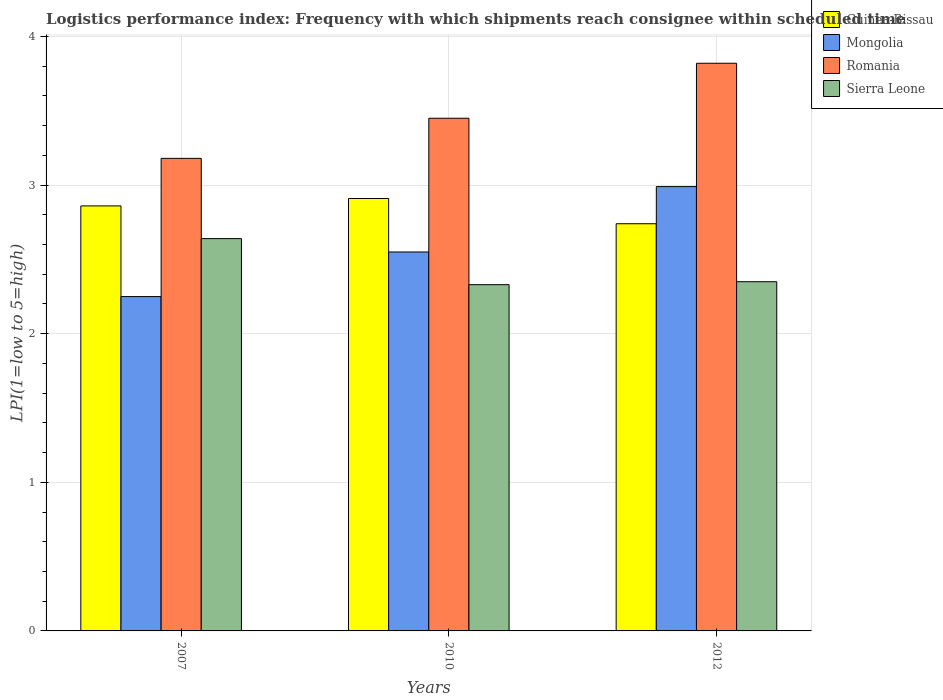How many different coloured bars are there?
Provide a short and direct response. 4. How many groups of bars are there?
Your response must be concise. 3. Are the number of bars on each tick of the X-axis equal?
Your answer should be very brief. Yes. How many bars are there on the 3rd tick from the right?
Keep it short and to the point. 4. What is the label of the 2nd group of bars from the left?
Offer a terse response. 2010. What is the logistics performance index in Sierra Leone in 2010?
Provide a succinct answer. 2.33. Across all years, what is the maximum logistics performance index in Guinea-Bissau?
Give a very brief answer. 2.91. Across all years, what is the minimum logistics performance index in Sierra Leone?
Give a very brief answer. 2.33. In which year was the logistics performance index in Romania maximum?
Keep it short and to the point. 2012. What is the total logistics performance index in Sierra Leone in the graph?
Make the answer very short. 7.32. What is the difference between the logistics performance index in Mongolia in 2010 and that in 2012?
Your response must be concise. -0.44. What is the difference between the logistics performance index in Mongolia in 2010 and the logistics performance index in Guinea-Bissau in 2012?
Give a very brief answer. -0.19. What is the average logistics performance index in Guinea-Bissau per year?
Ensure brevity in your answer.  2.84. In the year 2012, what is the difference between the logistics performance index in Guinea-Bissau and logistics performance index in Romania?
Offer a terse response. -1.08. In how many years, is the logistics performance index in Mongolia greater than 0.6000000000000001?
Ensure brevity in your answer.  3. What is the ratio of the logistics performance index in Sierra Leone in 2007 to that in 2010?
Make the answer very short. 1.13. Is the difference between the logistics performance index in Guinea-Bissau in 2007 and 2010 greater than the difference between the logistics performance index in Romania in 2007 and 2010?
Provide a succinct answer. Yes. What is the difference between the highest and the second highest logistics performance index in Guinea-Bissau?
Provide a succinct answer. 0.05. What is the difference between the highest and the lowest logistics performance index in Sierra Leone?
Give a very brief answer. 0.31. Is it the case that in every year, the sum of the logistics performance index in Sierra Leone and logistics performance index in Guinea-Bissau is greater than the sum of logistics performance index in Mongolia and logistics performance index in Romania?
Give a very brief answer. No. What does the 4th bar from the left in 2010 represents?
Your answer should be compact. Sierra Leone. What does the 1st bar from the right in 2007 represents?
Your answer should be very brief. Sierra Leone. Is it the case that in every year, the sum of the logistics performance index in Romania and logistics performance index in Mongolia is greater than the logistics performance index in Sierra Leone?
Make the answer very short. Yes. How many years are there in the graph?
Provide a succinct answer. 3. What is the difference between two consecutive major ticks on the Y-axis?
Give a very brief answer. 1. Does the graph contain any zero values?
Ensure brevity in your answer.  No. Where does the legend appear in the graph?
Your answer should be compact. Top right. How are the legend labels stacked?
Keep it short and to the point. Vertical. What is the title of the graph?
Provide a short and direct response. Logistics performance index: Frequency with which shipments reach consignee within scheduled time. Does "Peru" appear as one of the legend labels in the graph?
Make the answer very short. No. What is the label or title of the X-axis?
Your answer should be very brief. Years. What is the label or title of the Y-axis?
Ensure brevity in your answer.  LPI(1=low to 5=high). What is the LPI(1=low to 5=high) of Guinea-Bissau in 2007?
Your answer should be compact. 2.86. What is the LPI(1=low to 5=high) of Mongolia in 2007?
Offer a very short reply. 2.25. What is the LPI(1=low to 5=high) of Romania in 2007?
Your answer should be very brief. 3.18. What is the LPI(1=low to 5=high) in Sierra Leone in 2007?
Offer a very short reply. 2.64. What is the LPI(1=low to 5=high) of Guinea-Bissau in 2010?
Provide a succinct answer. 2.91. What is the LPI(1=low to 5=high) of Mongolia in 2010?
Your answer should be compact. 2.55. What is the LPI(1=low to 5=high) of Romania in 2010?
Your answer should be compact. 3.45. What is the LPI(1=low to 5=high) of Sierra Leone in 2010?
Provide a succinct answer. 2.33. What is the LPI(1=low to 5=high) of Guinea-Bissau in 2012?
Your response must be concise. 2.74. What is the LPI(1=low to 5=high) of Mongolia in 2012?
Offer a very short reply. 2.99. What is the LPI(1=low to 5=high) of Romania in 2012?
Ensure brevity in your answer.  3.82. What is the LPI(1=low to 5=high) in Sierra Leone in 2012?
Ensure brevity in your answer.  2.35. Across all years, what is the maximum LPI(1=low to 5=high) of Guinea-Bissau?
Keep it short and to the point. 2.91. Across all years, what is the maximum LPI(1=low to 5=high) in Mongolia?
Provide a succinct answer. 2.99. Across all years, what is the maximum LPI(1=low to 5=high) in Romania?
Give a very brief answer. 3.82. Across all years, what is the maximum LPI(1=low to 5=high) in Sierra Leone?
Ensure brevity in your answer.  2.64. Across all years, what is the minimum LPI(1=low to 5=high) of Guinea-Bissau?
Keep it short and to the point. 2.74. Across all years, what is the minimum LPI(1=low to 5=high) of Mongolia?
Provide a succinct answer. 2.25. Across all years, what is the minimum LPI(1=low to 5=high) in Romania?
Give a very brief answer. 3.18. Across all years, what is the minimum LPI(1=low to 5=high) of Sierra Leone?
Keep it short and to the point. 2.33. What is the total LPI(1=low to 5=high) of Guinea-Bissau in the graph?
Your answer should be compact. 8.51. What is the total LPI(1=low to 5=high) in Mongolia in the graph?
Your answer should be compact. 7.79. What is the total LPI(1=low to 5=high) in Romania in the graph?
Keep it short and to the point. 10.45. What is the total LPI(1=low to 5=high) in Sierra Leone in the graph?
Your answer should be very brief. 7.32. What is the difference between the LPI(1=low to 5=high) in Romania in 2007 and that in 2010?
Offer a terse response. -0.27. What is the difference between the LPI(1=low to 5=high) of Sierra Leone in 2007 and that in 2010?
Offer a very short reply. 0.31. What is the difference between the LPI(1=low to 5=high) in Guinea-Bissau in 2007 and that in 2012?
Provide a succinct answer. 0.12. What is the difference between the LPI(1=low to 5=high) of Mongolia in 2007 and that in 2012?
Your answer should be compact. -0.74. What is the difference between the LPI(1=low to 5=high) in Romania in 2007 and that in 2012?
Provide a succinct answer. -0.64. What is the difference between the LPI(1=low to 5=high) in Sierra Leone in 2007 and that in 2012?
Ensure brevity in your answer.  0.29. What is the difference between the LPI(1=low to 5=high) in Guinea-Bissau in 2010 and that in 2012?
Keep it short and to the point. 0.17. What is the difference between the LPI(1=low to 5=high) in Mongolia in 2010 and that in 2012?
Offer a very short reply. -0.44. What is the difference between the LPI(1=low to 5=high) of Romania in 2010 and that in 2012?
Your response must be concise. -0.37. What is the difference between the LPI(1=low to 5=high) of Sierra Leone in 2010 and that in 2012?
Keep it short and to the point. -0.02. What is the difference between the LPI(1=low to 5=high) in Guinea-Bissau in 2007 and the LPI(1=low to 5=high) in Mongolia in 2010?
Your response must be concise. 0.31. What is the difference between the LPI(1=low to 5=high) in Guinea-Bissau in 2007 and the LPI(1=low to 5=high) in Romania in 2010?
Your response must be concise. -0.59. What is the difference between the LPI(1=low to 5=high) in Guinea-Bissau in 2007 and the LPI(1=low to 5=high) in Sierra Leone in 2010?
Your answer should be very brief. 0.53. What is the difference between the LPI(1=low to 5=high) of Mongolia in 2007 and the LPI(1=low to 5=high) of Sierra Leone in 2010?
Your answer should be compact. -0.08. What is the difference between the LPI(1=low to 5=high) in Guinea-Bissau in 2007 and the LPI(1=low to 5=high) in Mongolia in 2012?
Offer a terse response. -0.13. What is the difference between the LPI(1=low to 5=high) in Guinea-Bissau in 2007 and the LPI(1=low to 5=high) in Romania in 2012?
Offer a terse response. -0.96. What is the difference between the LPI(1=low to 5=high) of Guinea-Bissau in 2007 and the LPI(1=low to 5=high) of Sierra Leone in 2012?
Keep it short and to the point. 0.51. What is the difference between the LPI(1=low to 5=high) in Mongolia in 2007 and the LPI(1=low to 5=high) in Romania in 2012?
Your answer should be compact. -1.57. What is the difference between the LPI(1=low to 5=high) of Romania in 2007 and the LPI(1=low to 5=high) of Sierra Leone in 2012?
Offer a terse response. 0.83. What is the difference between the LPI(1=low to 5=high) of Guinea-Bissau in 2010 and the LPI(1=low to 5=high) of Mongolia in 2012?
Offer a terse response. -0.08. What is the difference between the LPI(1=low to 5=high) in Guinea-Bissau in 2010 and the LPI(1=low to 5=high) in Romania in 2012?
Ensure brevity in your answer.  -0.91. What is the difference between the LPI(1=low to 5=high) of Guinea-Bissau in 2010 and the LPI(1=low to 5=high) of Sierra Leone in 2012?
Your answer should be compact. 0.56. What is the difference between the LPI(1=low to 5=high) in Mongolia in 2010 and the LPI(1=low to 5=high) in Romania in 2012?
Keep it short and to the point. -1.27. What is the average LPI(1=low to 5=high) of Guinea-Bissau per year?
Ensure brevity in your answer.  2.84. What is the average LPI(1=low to 5=high) of Mongolia per year?
Make the answer very short. 2.6. What is the average LPI(1=low to 5=high) in Romania per year?
Your response must be concise. 3.48. What is the average LPI(1=low to 5=high) of Sierra Leone per year?
Your answer should be very brief. 2.44. In the year 2007, what is the difference between the LPI(1=low to 5=high) of Guinea-Bissau and LPI(1=low to 5=high) of Mongolia?
Provide a short and direct response. 0.61. In the year 2007, what is the difference between the LPI(1=low to 5=high) of Guinea-Bissau and LPI(1=low to 5=high) of Romania?
Keep it short and to the point. -0.32. In the year 2007, what is the difference between the LPI(1=low to 5=high) in Guinea-Bissau and LPI(1=low to 5=high) in Sierra Leone?
Your answer should be very brief. 0.22. In the year 2007, what is the difference between the LPI(1=low to 5=high) in Mongolia and LPI(1=low to 5=high) in Romania?
Your response must be concise. -0.93. In the year 2007, what is the difference between the LPI(1=low to 5=high) of Mongolia and LPI(1=low to 5=high) of Sierra Leone?
Offer a very short reply. -0.39. In the year 2007, what is the difference between the LPI(1=low to 5=high) of Romania and LPI(1=low to 5=high) of Sierra Leone?
Offer a very short reply. 0.54. In the year 2010, what is the difference between the LPI(1=low to 5=high) of Guinea-Bissau and LPI(1=low to 5=high) of Mongolia?
Offer a very short reply. 0.36. In the year 2010, what is the difference between the LPI(1=low to 5=high) in Guinea-Bissau and LPI(1=low to 5=high) in Romania?
Ensure brevity in your answer.  -0.54. In the year 2010, what is the difference between the LPI(1=low to 5=high) of Guinea-Bissau and LPI(1=low to 5=high) of Sierra Leone?
Give a very brief answer. 0.58. In the year 2010, what is the difference between the LPI(1=low to 5=high) in Mongolia and LPI(1=low to 5=high) in Sierra Leone?
Offer a very short reply. 0.22. In the year 2010, what is the difference between the LPI(1=low to 5=high) of Romania and LPI(1=low to 5=high) of Sierra Leone?
Keep it short and to the point. 1.12. In the year 2012, what is the difference between the LPI(1=low to 5=high) of Guinea-Bissau and LPI(1=low to 5=high) of Mongolia?
Keep it short and to the point. -0.25. In the year 2012, what is the difference between the LPI(1=low to 5=high) of Guinea-Bissau and LPI(1=low to 5=high) of Romania?
Your answer should be compact. -1.08. In the year 2012, what is the difference between the LPI(1=low to 5=high) of Guinea-Bissau and LPI(1=low to 5=high) of Sierra Leone?
Give a very brief answer. 0.39. In the year 2012, what is the difference between the LPI(1=low to 5=high) of Mongolia and LPI(1=low to 5=high) of Romania?
Ensure brevity in your answer.  -0.83. In the year 2012, what is the difference between the LPI(1=low to 5=high) in Mongolia and LPI(1=low to 5=high) in Sierra Leone?
Ensure brevity in your answer.  0.64. In the year 2012, what is the difference between the LPI(1=low to 5=high) of Romania and LPI(1=low to 5=high) of Sierra Leone?
Your response must be concise. 1.47. What is the ratio of the LPI(1=low to 5=high) in Guinea-Bissau in 2007 to that in 2010?
Your answer should be compact. 0.98. What is the ratio of the LPI(1=low to 5=high) in Mongolia in 2007 to that in 2010?
Offer a very short reply. 0.88. What is the ratio of the LPI(1=low to 5=high) in Romania in 2007 to that in 2010?
Offer a terse response. 0.92. What is the ratio of the LPI(1=low to 5=high) of Sierra Leone in 2007 to that in 2010?
Make the answer very short. 1.13. What is the ratio of the LPI(1=low to 5=high) in Guinea-Bissau in 2007 to that in 2012?
Make the answer very short. 1.04. What is the ratio of the LPI(1=low to 5=high) in Mongolia in 2007 to that in 2012?
Provide a succinct answer. 0.75. What is the ratio of the LPI(1=low to 5=high) of Romania in 2007 to that in 2012?
Offer a very short reply. 0.83. What is the ratio of the LPI(1=low to 5=high) of Sierra Leone in 2007 to that in 2012?
Ensure brevity in your answer.  1.12. What is the ratio of the LPI(1=low to 5=high) in Guinea-Bissau in 2010 to that in 2012?
Ensure brevity in your answer.  1.06. What is the ratio of the LPI(1=low to 5=high) of Mongolia in 2010 to that in 2012?
Your response must be concise. 0.85. What is the ratio of the LPI(1=low to 5=high) in Romania in 2010 to that in 2012?
Ensure brevity in your answer.  0.9. What is the difference between the highest and the second highest LPI(1=low to 5=high) of Guinea-Bissau?
Your answer should be very brief. 0.05. What is the difference between the highest and the second highest LPI(1=low to 5=high) of Mongolia?
Keep it short and to the point. 0.44. What is the difference between the highest and the second highest LPI(1=low to 5=high) of Romania?
Your response must be concise. 0.37. What is the difference between the highest and the second highest LPI(1=low to 5=high) of Sierra Leone?
Ensure brevity in your answer.  0.29. What is the difference between the highest and the lowest LPI(1=low to 5=high) in Guinea-Bissau?
Your answer should be compact. 0.17. What is the difference between the highest and the lowest LPI(1=low to 5=high) in Mongolia?
Your response must be concise. 0.74. What is the difference between the highest and the lowest LPI(1=low to 5=high) in Romania?
Your answer should be very brief. 0.64. What is the difference between the highest and the lowest LPI(1=low to 5=high) in Sierra Leone?
Provide a succinct answer. 0.31. 